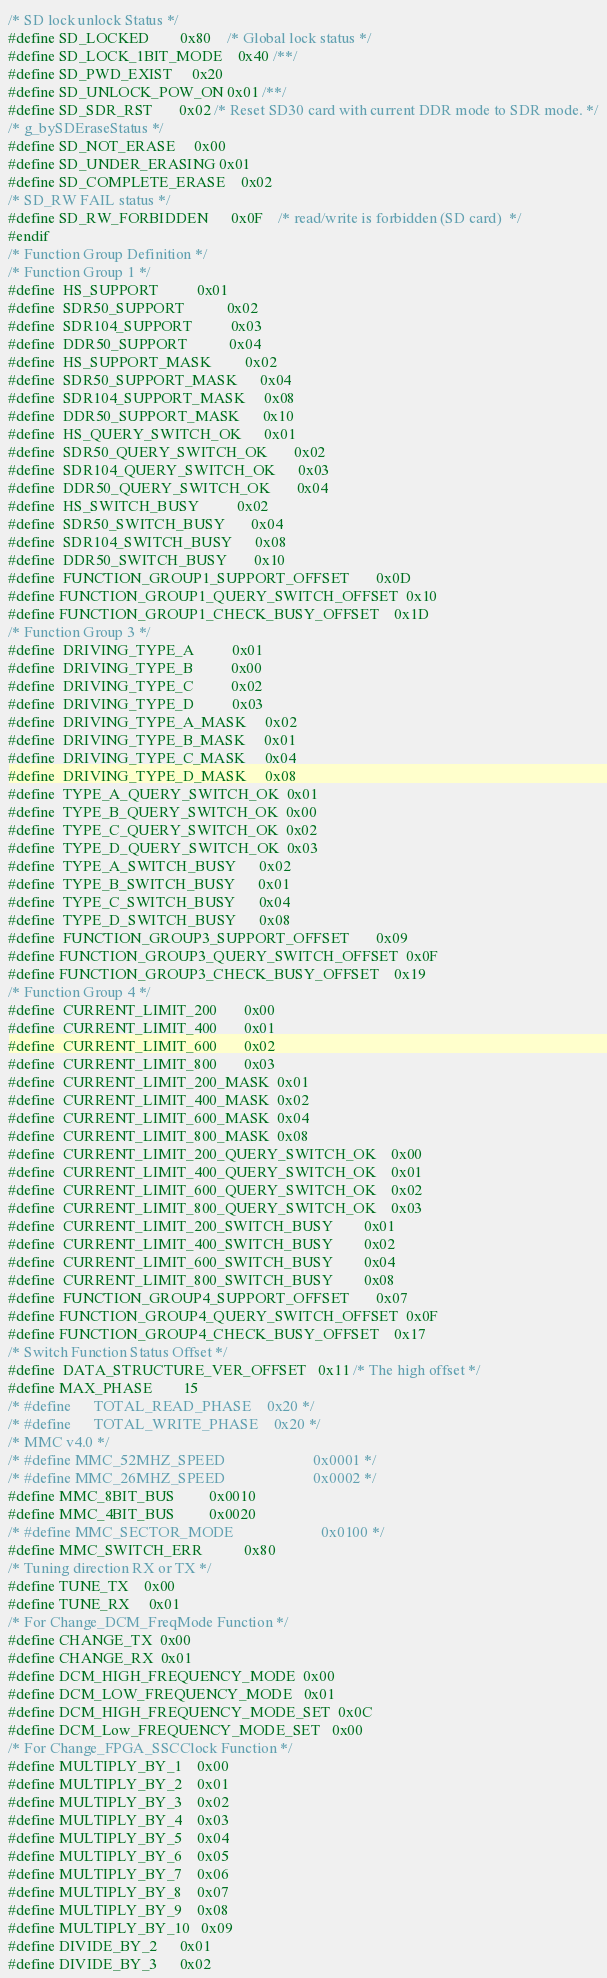<code> <loc_0><loc_0><loc_500><loc_500><_C_>/* SD lock unlock Status */
#define SD_LOCKED		0x80	/* Global lock status */
#define SD_LOCK_1BIT_MODE	0x40 /**/
#define SD_PWD_EXIST		0x20
#define SD_UNLOCK_POW_ON	0x01 /**/
#define SD_SDR_RST		0x02 /* Reset SD30 card with current DDR mode to SDR mode. */
/* g_bySDEraseStatus */
#define SD_NOT_ERASE		0x00
#define SD_UNDER_ERASING	0x01
#define SD_COMPLETE_ERASE	0x02
/* SD_RW FAIL status */
#define SD_RW_FORBIDDEN		0x0F	/* read/write is forbidden (SD card)  */
#endif
/* Function Group Definition */
/* Function Group 1 */
#define	HS_SUPPORT			0x01
#define	SDR50_SUPPORT			0x02
#define	SDR104_SUPPORT			0x03
#define	DDR50_SUPPORT			0x04
#define	HS_SUPPORT_MASK			0x02
#define	SDR50_SUPPORT_MASK		0x04
#define	SDR104_SUPPORT_MASK		0x08
#define	DDR50_SUPPORT_MASK		0x10
#define	HS_QUERY_SWITCH_OK		0x01
#define	SDR50_QUERY_SWITCH_OK		0x02
#define	SDR104_QUERY_SWITCH_OK		0x03
#define	DDR50_QUERY_SWITCH_OK		0x04
#define	HS_SWITCH_BUSY			0x02
#define	SDR50_SWITCH_BUSY		0x04
#define	SDR104_SWITCH_BUSY		0x08
#define	DDR50_SWITCH_BUSY		0x10
#define	FUNCTION_GROUP1_SUPPORT_OFFSET       0x0D
#define FUNCTION_GROUP1_QUERY_SWITCH_OFFSET  0x10
#define FUNCTION_GROUP1_CHECK_BUSY_OFFSET    0x1D
/* Function Group 3 */
#define	DRIVING_TYPE_A	        0x01
#define	DRIVING_TYPE_B		    0x00
#define	DRIVING_TYPE_C		    0x02
#define	DRIVING_TYPE_D	        0x03
#define	DRIVING_TYPE_A_MASK	    0x02
#define	DRIVING_TYPE_B_MASK	    0x01
#define	DRIVING_TYPE_C_MASK	    0x04
#define	DRIVING_TYPE_D_MASK	    0x08
#define	TYPE_A_QUERY_SWITCH_OK	0x01
#define	TYPE_B_QUERY_SWITCH_OK	0x00
#define	TYPE_C_QUERY_SWITCH_OK  0x02
#define	TYPE_D_QUERY_SWITCH_OK  0x03
#define	TYPE_A_SWITCH_BUSY	    0x02
#define	TYPE_B_SWITCH_BUSY	    0x01
#define	TYPE_C_SWITCH_BUSY      0x04
#define	TYPE_D_SWITCH_BUSY      0x08
#define	FUNCTION_GROUP3_SUPPORT_OFFSET       0x09
#define FUNCTION_GROUP3_QUERY_SWITCH_OFFSET  0x0F
#define FUNCTION_GROUP3_CHECK_BUSY_OFFSET    0x19
/* Function Group 4 */
#define	CURRENT_LIMIT_200	    0x00
#define	CURRENT_LIMIT_400	    0x01
#define	CURRENT_LIMIT_600	    0x02
#define	CURRENT_LIMIT_800	    0x03
#define	CURRENT_LIMIT_200_MASK	0x01
#define	CURRENT_LIMIT_400_MASK	0x02
#define	CURRENT_LIMIT_600_MASK	0x04
#define	CURRENT_LIMIT_800_MASK	0x08
#define	CURRENT_LIMIT_200_QUERY_SWITCH_OK    0x00
#define	CURRENT_LIMIT_400_QUERY_SWITCH_OK    0x01
#define	CURRENT_LIMIT_600_QUERY_SWITCH_OK    0x02
#define	CURRENT_LIMIT_800_QUERY_SWITCH_OK    0x03
#define	CURRENT_LIMIT_200_SWITCH_BUSY        0x01
#define	CURRENT_LIMIT_400_SWITCH_BUSY	     0x02
#define	CURRENT_LIMIT_600_SWITCH_BUSY        0x04
#define	CURRENT_LIMIT_800_SWITCH_BUSY        0x08
#define	FUNCTION_GROUP4_SUPPORT_OFFSET       0x07
#define FUNCTION_GROUP4_QUERY_SWITCH_OFFSET  0x0F
#define FUNCTION_GROUP4_CHECK_BUSY_OFFSET    0x17
/* Switch Function Status Offset */
#define	DATA_STRUCTURE_VER_OFFSET   0x11 /* The high offset */
#define MAX_PHASE		15
/* #define      TOTAL_READ_PHASE    0x20 */
/* #define      TOTAL_WRITE_PHASE    0x20 */
/* MMC v4.0 */
/* #define MMC_52MHZ_SPEED                       0x0001 */
/* #define MMC_26MHZ_SPEED                       0x0002 */
#define MMC_8BIT_BUS			0x0010
#define MMC_4BIT_BUS			0x0020
/* #define MMC_SECTOR_MODE                       0x0100 */
#define MMC_SWITCH_ERR			0x80
/* Tuning direction RX or TX */
#define TUNE_TX    0x00
#define TUNE_RX	   0x01
/* For Change_DCM_FreqMode Function */
#define CHANGE_TX  0x00
#define CHANGE_RX  0x01
#define DCM_HIGH_FREQUENCY_MODE  0x00
#define DCM_LOW_FREQUENCY_MODE   0x01
#define DCM_HIGH_FREQUENCY_MODE_SET  0x0C
#define DCM_Low_FREQUENCY_MODE_SET   0x00
/* For Change_FPGA_SSCClock Function */
#define MULTIPLY_BY_1    0x00
#define MULTIPLY_BY_2    0x01
#define MULTIPLY_BY_3    0x02
#define MULTIPLY_BY_4    0x03
#define MULTIPLY_BY_5    0x04
#define MULTIPLY_BY_6    0x05
#define MULTIPLY_BY_7    0x06
#define MULTIPLY_BY_8    0x07
#define MULTIPLY_BY_9    0x08
#define MULTIPLY_BY_10   0x09
#define DIVIDE_BY_2      0x01
#define DIVIDE_BY_3      0x02</code> 